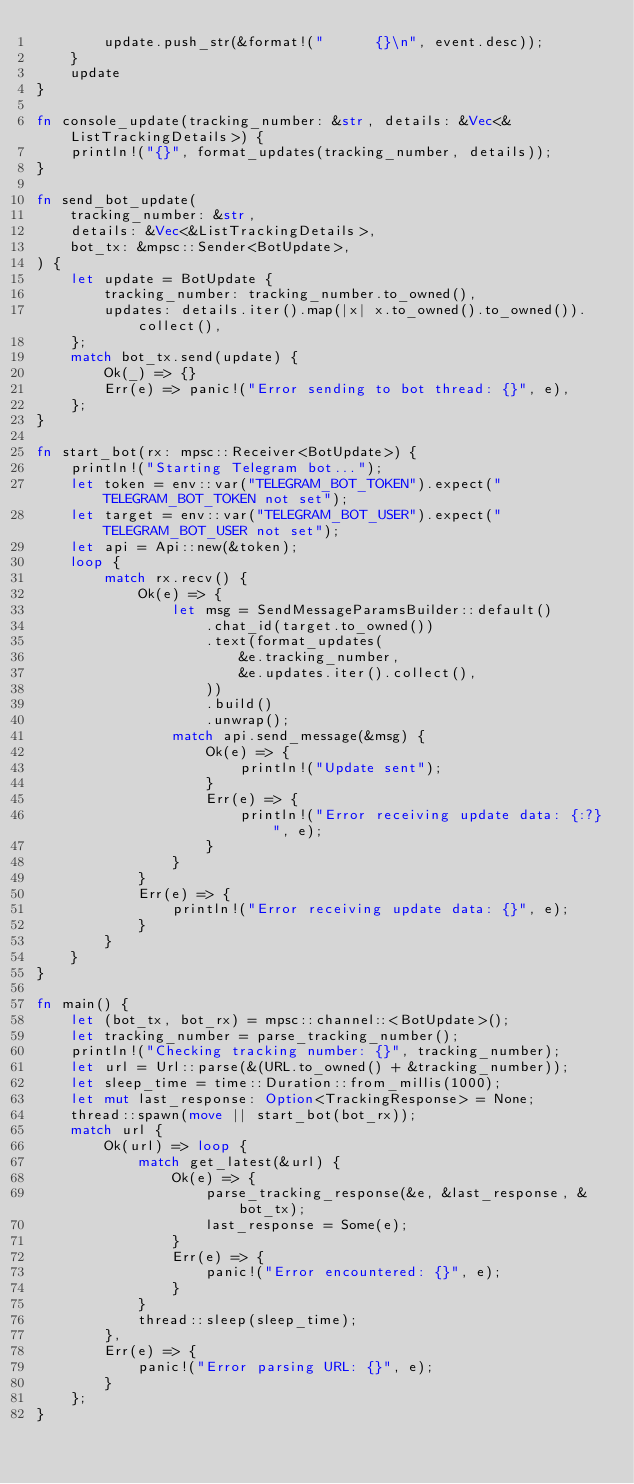<code> <loc_0><loc_0><loc_500><loc_500><_Rust_>        update.push_str(&format!("      {}\n", event.desc));
    }
    update
}

fn console_update(tracking_number: &str, details: &Vec<&ListTrackingDetails>) {
    println!("{}", format_updates(tracking_number, details));
}

fn send_bot_update(
    tracking_number: &str,
    details: &Vec<&ListTrackingDetails>,
    bot_tx: &mpsc::Sender<BotUpdate>,
) {
    let update = BotUpdate {
        tracking_number: tracking_number.to_owned(),
        updates: details.iter().map(|x| x.to_owned().to_owned()).collect(),
    };
    match bot_tx.send(update) {
        Ok(_) => {}
        Err(e) => panic!("Error sending to bot thread: {}", e),
    };
}

fn start_bot(rx: mpsc::Receiver<BotUpdate>) {
    println!("Starting Telegram bot...");
    let token = env::var("TELEGRAM_BOT_TOKEN").expect("TELEGRAM_BOT_TOKEN not set");
    let target = env::var("TELEGRAM_BOT_USER").expect("TELEGRAM_BOT_USER not set");
    let api = Api::new(&token);
    loop {
        match rx.recv() {
            Ok(e) => {
                let msg = SendMessageParamsBuilder::default()
                    .chat_id(target.to_owned())
                    .text(format_updates(
                        &e.tracking_number,
                        &e.updates.iter().collect(),
                    ))
                    .build()
                    .unwrap();
                match api.send_message(&msg) {
                    Ok(e) => {
                        println!("Update sent");
                    }
                    Err(e) => {
                        println!("Error receiving update data: {:?}", e);
                    }
                }
            }
            Err(e) => {
                println!("Error receiving update data: {}", e);
            }
        }
    }
}

fn main() {
    let (bot_tx, bot_rx) = mpsc::channel::<BotUpdate>();
    let tracking_number = parse_tracking_number();
    println!("Checking tracking number: {}", tracking_number);
    let url = Url::parse(&(URL.to_owned() + &tracking_number));
    let sleep_time = time::Duration::from_millis(1000);
    let mut last_response: Option<TrackingResponse> = None;
    thread::spawn(move || start_bot(bot_rx));
    match url {
        Ok(url) => loop {
            match get_latest(&url) {
                Ok(e) => {
                    parse_tracking_response(&e, &last_response, &bot_tx);
                    last_response = Some(e);
                }
                Err(e) => {
                    panic!("Error encountered: {}", e);
                }
            }
            thread::sleep(sleep_time);
        },
        Err(e) => {
            panic!("Error parsing URL: {}", e);
        }
    };
}
</code> 